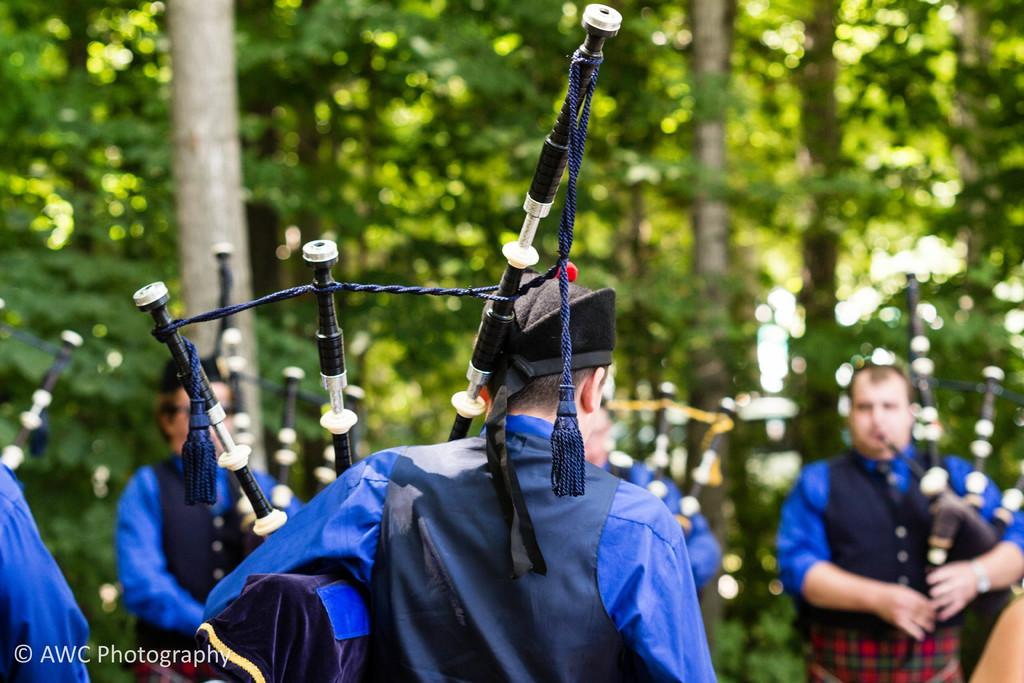What are the people in the image doing? The people in the image are playing pipes. What can be seen in the background of the image? There are trees in the background of the image. How would you describe the background of the image? The background is blurred. Where is the text located in the image? The text is in the bottom left corner of the image. What type of shoes can be seen on the people playing pipes in the image? There is no information about shoes in the image, as it focuses on the people playing pipes and the background. 